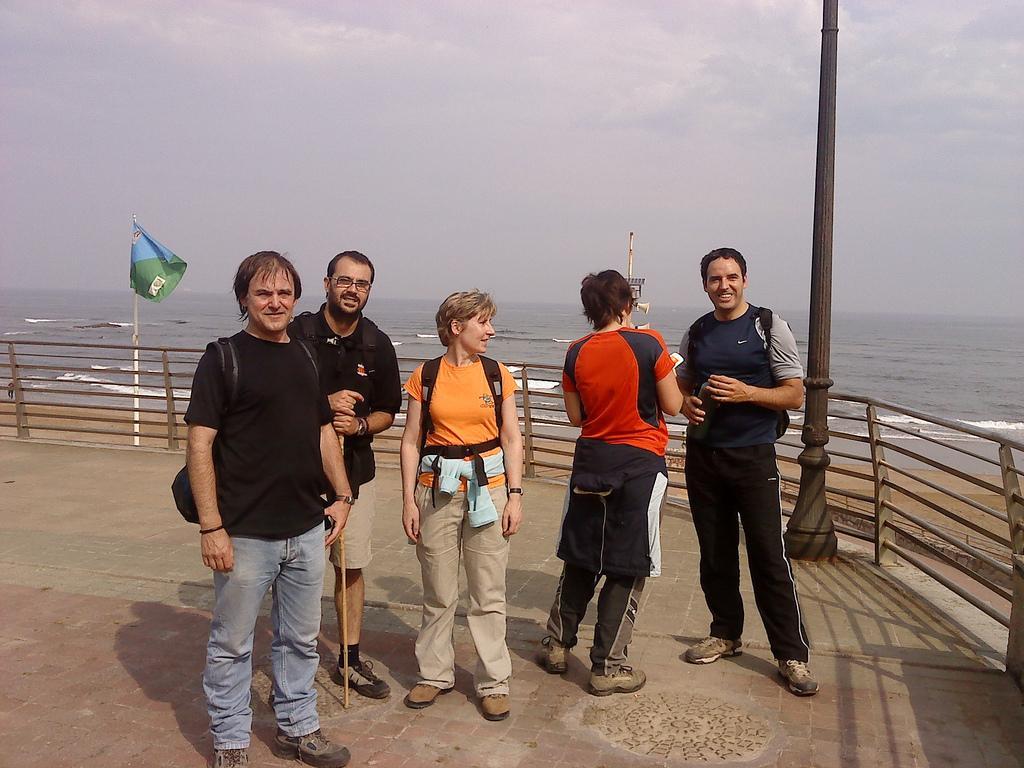Can you describe this image briefly? In this image I can see group of people standing. In front the person is wearing black and blue color dress. Background I can see the fencing and the flag is in blue and green color. I can also see the water and the sky is in white color. 